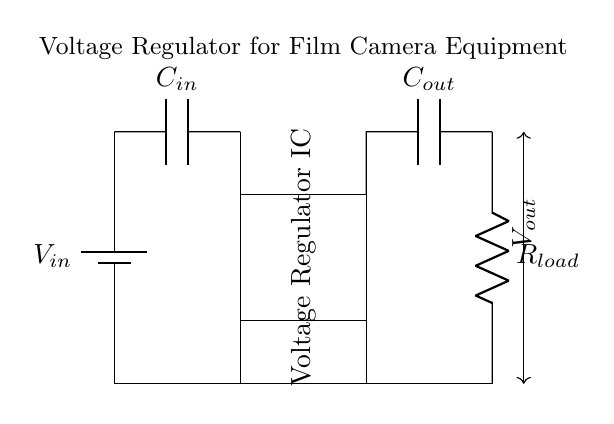What is the input voltage source labeled as? The input voltage source is labeled as V_in, which indicates the voltage supplied to the regulator circuit.
Answer: V_in What is the purpose of the capacitor labeled C_out? C_out is an output capacitor that smooths the output voltage and helps maintain stability in the power supply to the load.
Answer: Output stabilization What type of component is represented by the rectangle in the circuit graph? The rectangle represents a Voltage Regulator IC, which is responsible for regulating the output voltage to a stable level regardless of input variations.
Answer: Voltage Regulator IC How many capacitors are present in the circuit? There are two capacitors in the circuit: C_in and C_out, which serve different purposes for input filtering and output stabilization.
Answer: Two What is the load connected to the output of the voltage regulator? The load connected to the output is represented by the resistor labeled R_load, indicating the device or component drawing power from the regulated output.
Answer: R_load What is the relationship between V_in and V_out in this setup? The voltage regulator IC decreases the input voltage V_in to a lower, stable output voltage V_out that is suitable for the film camera equipment.
Answer: V_out < V_in What is the role of the input capacitor C_in in the circuit? The input capacitor C_in filters any noise and provides a stable voltage at the input of the voltage regulator, thus improving performance.
Answer: Input filtering 